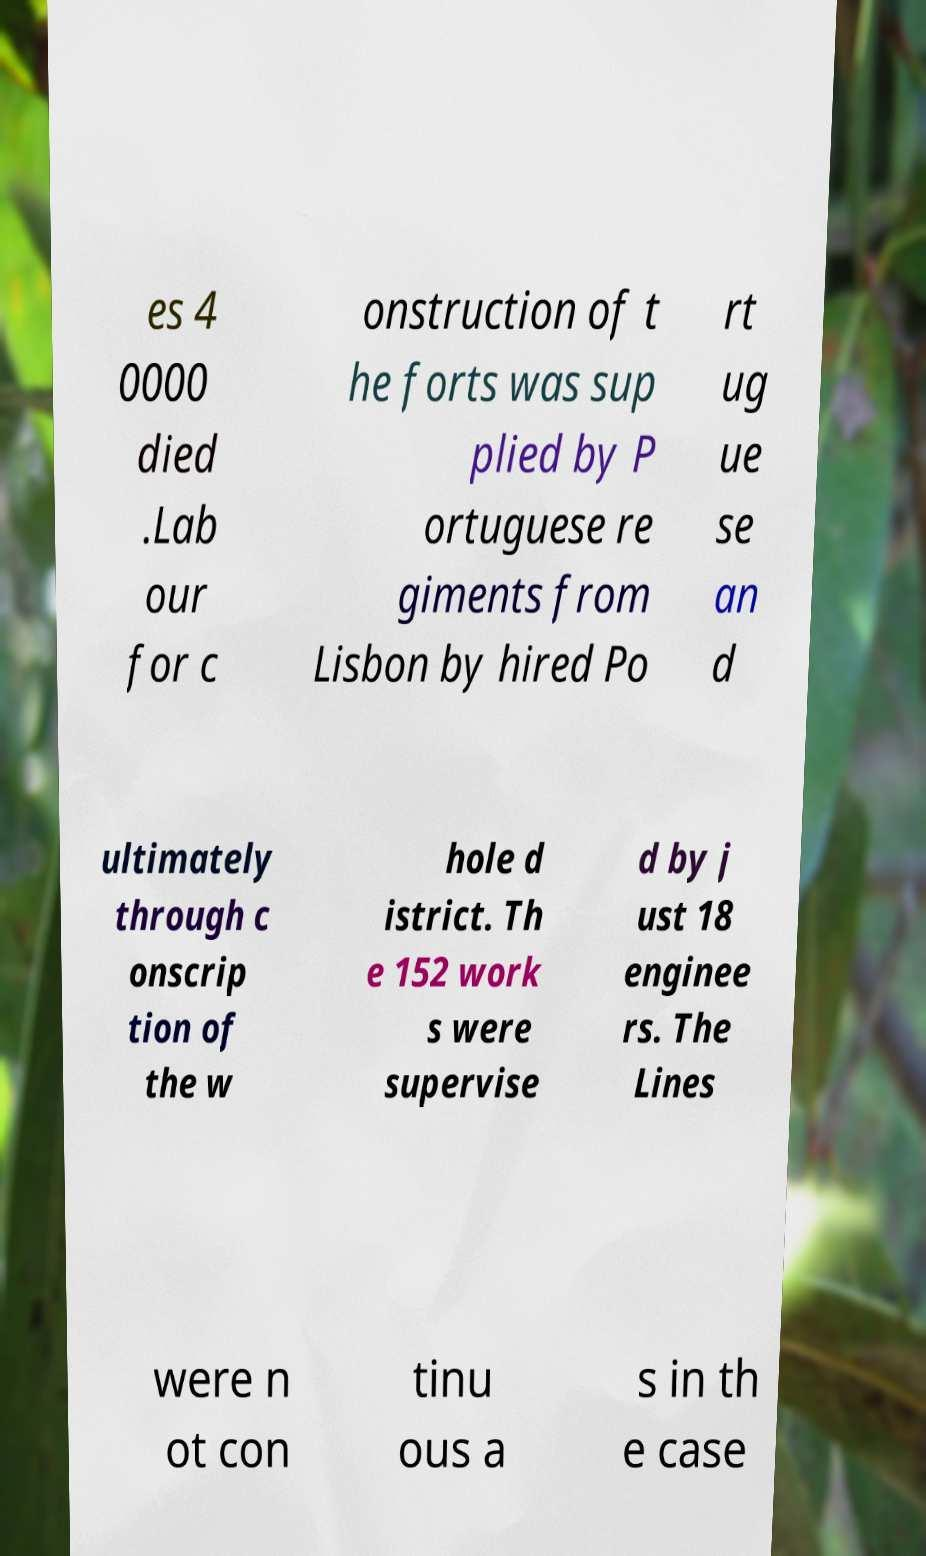Please identify and transcribe the text found in this image. es 4 0000 died .Lab our for c onstruction of t he forts was sup plied by P ortuguese re giments from Lisbon by hired Po rt ug ue se an d ultimately through c onscrip tion of the w hole d istrict. Th e 152 work s were supervise d by j ust 18 enginee rs. The Lines were n ot con tinu ous a s in th e case 